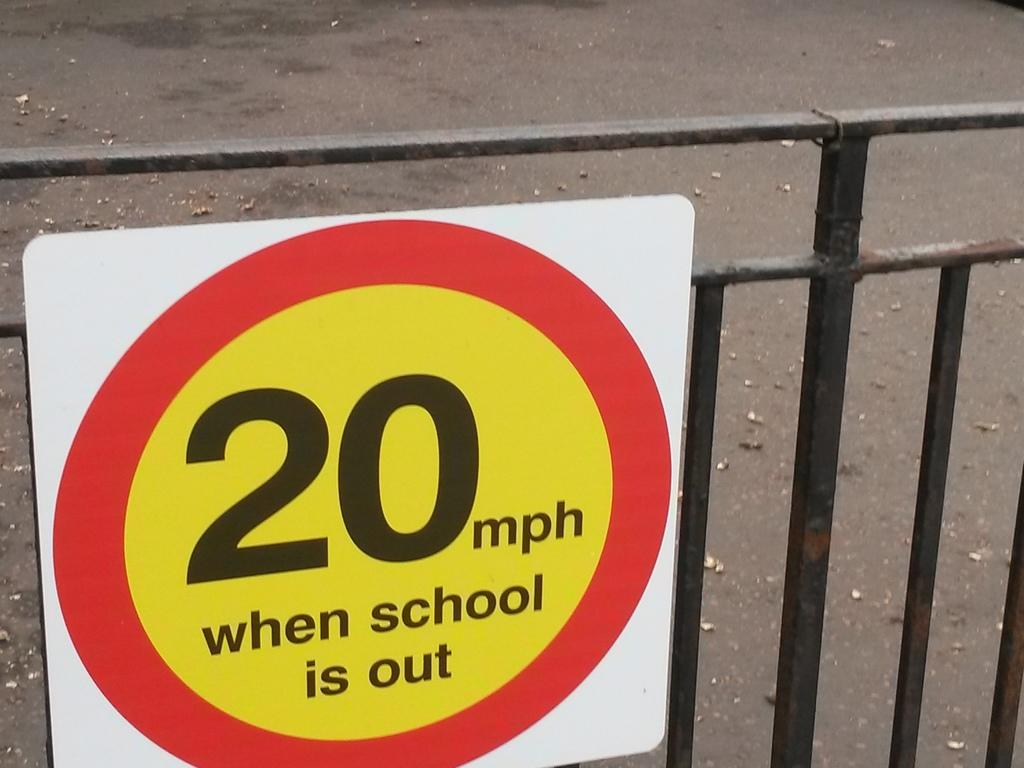<image>
Share a concise interpretation of the image provided. A sign attached to a metal gate warns that the speed limit is 20 mph when school is out. 